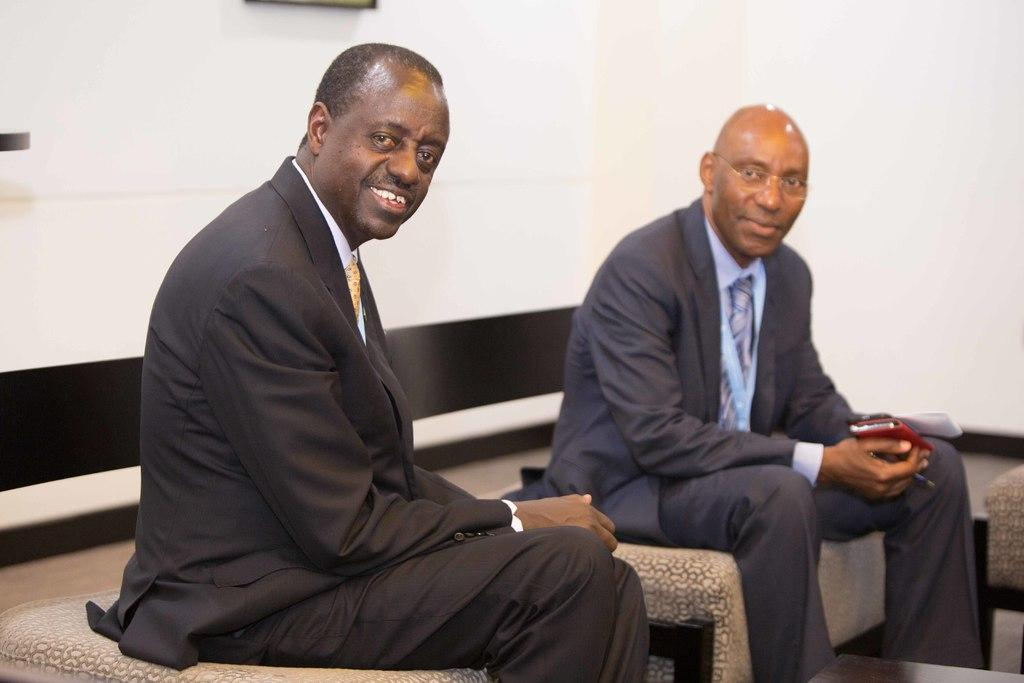How many people are present in the image? There are two persons sitting in the image. Can you describe the appearance of one of the persons? One of the persons is wearing specs. What is the person wearing specs holding in their hand? The person wearing specs is holding a mobile. What can be seen in the background of the image? There is a wall in the background of the image. Is there a rainstorm happening in the image? No, there is no indication of a rainstorm in the image. Can you see the coast in the image? No, the coast is not visible in the image. 